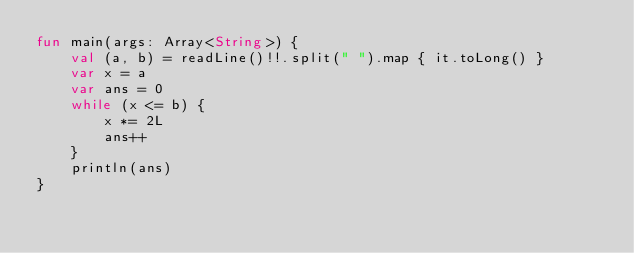<code> <loc_0><loc_0><loc_500><loc_500><_Kotlin_>fun main(args: Array<String>) {
    val (a, b) = readLine()!!.split(" ").map { it.toLong() }
    var x = a
    var ans = 0
    while (x <= b) {
        x *= 2L
        ans++
    }
    println(ans)
}
</code> 